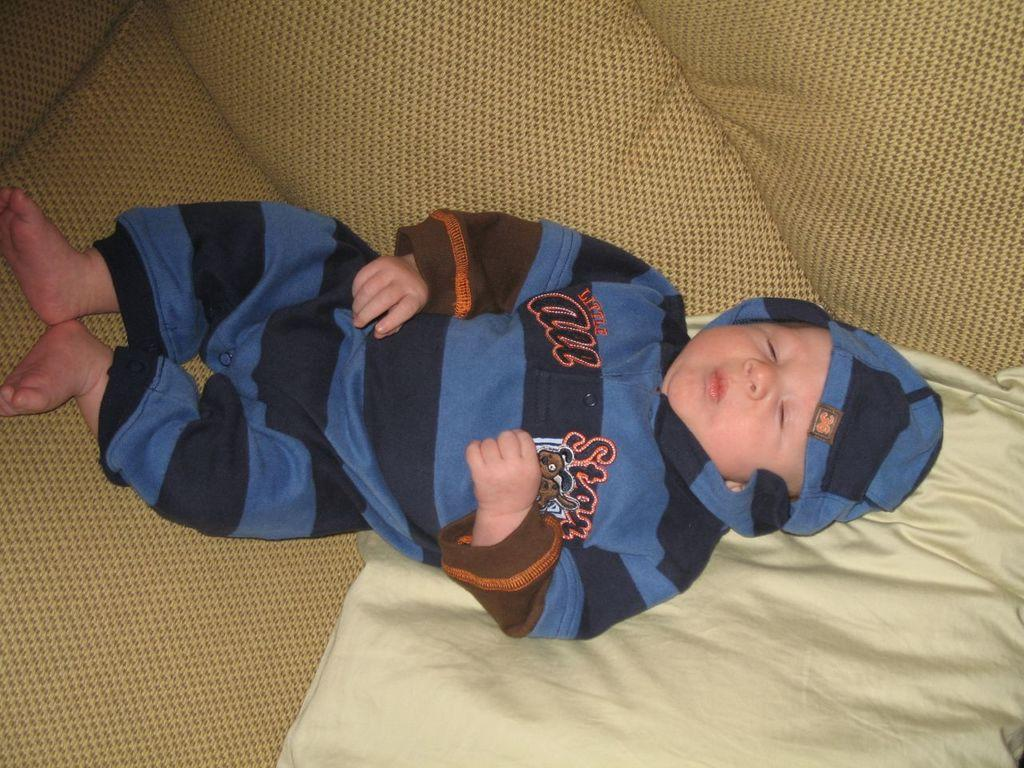What is the main subject of the image? The main subject of the image is a baby. What is the baby doing in the image? The baby is lying on the bed. What can be seen underneath the baby in the image? There is a bed sheet visible in the image. What word is the baby trying to say in the image? There is no indication in the image that the baby is trying to say any word. What type of view can be seen from the baby's perspective in the image? The image does not provide enough context to determine the view from the baby's perspective. 